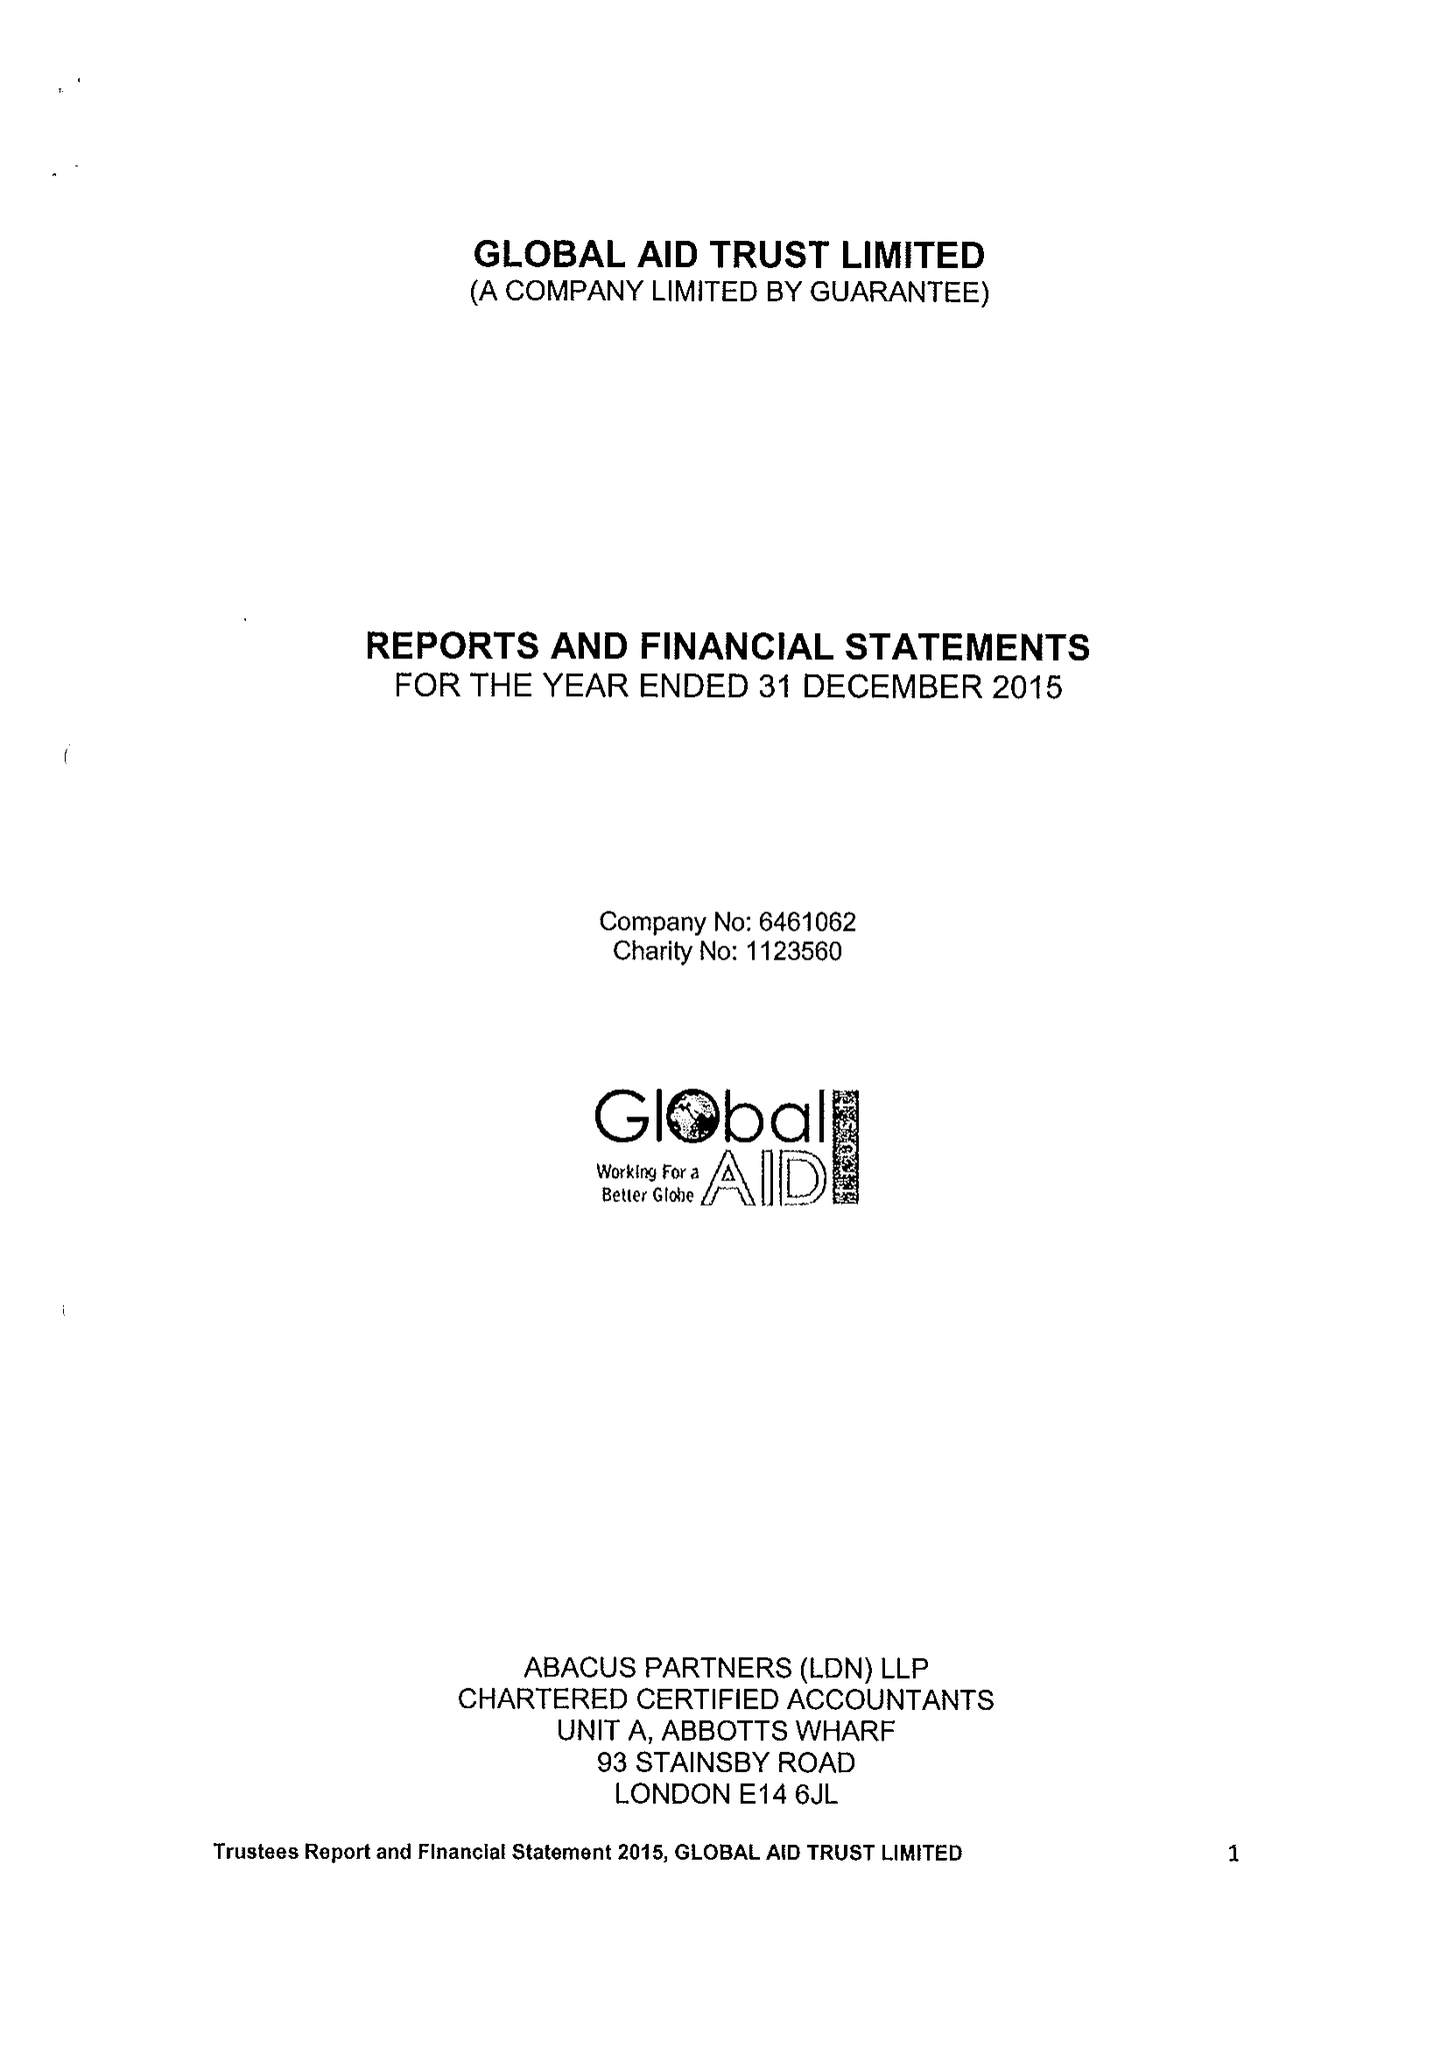What is the value for the charity_name?
Answer the question using a single word or phrase. Global Aid Trust Ltd. 